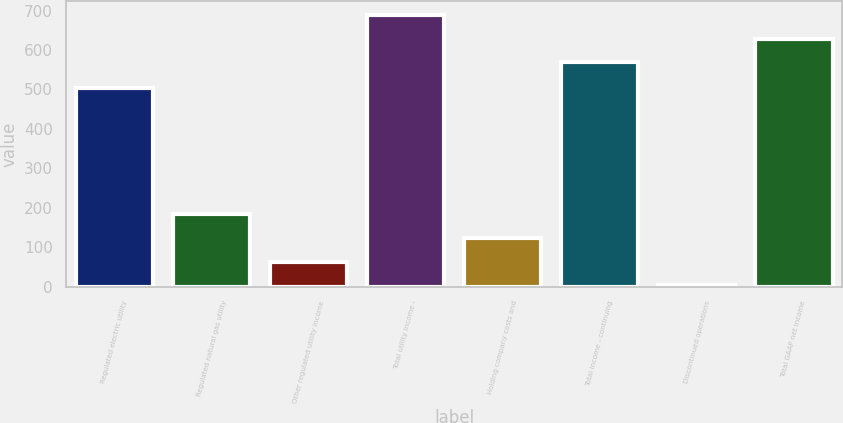Convert chart. <chart><loc_0><loc_0><loc_500><loc_500><bar_chart><fcel>Regulated electric utility<fcel>Regulated natural gas utility<fcel>Other regulated utility income<fcel>Total utility income -<fcel>Holding company costs and<fcel>Total income - continuing<fcel>Discontinued operations<fcel>Total GAAP net income<nl><fcel>503.1<fcel>183.97<fcel>63.39<fcel>689.28<fcel>123.68<fcel>568.7<fcel>3.1<fcel>628.99<nl></chart> 